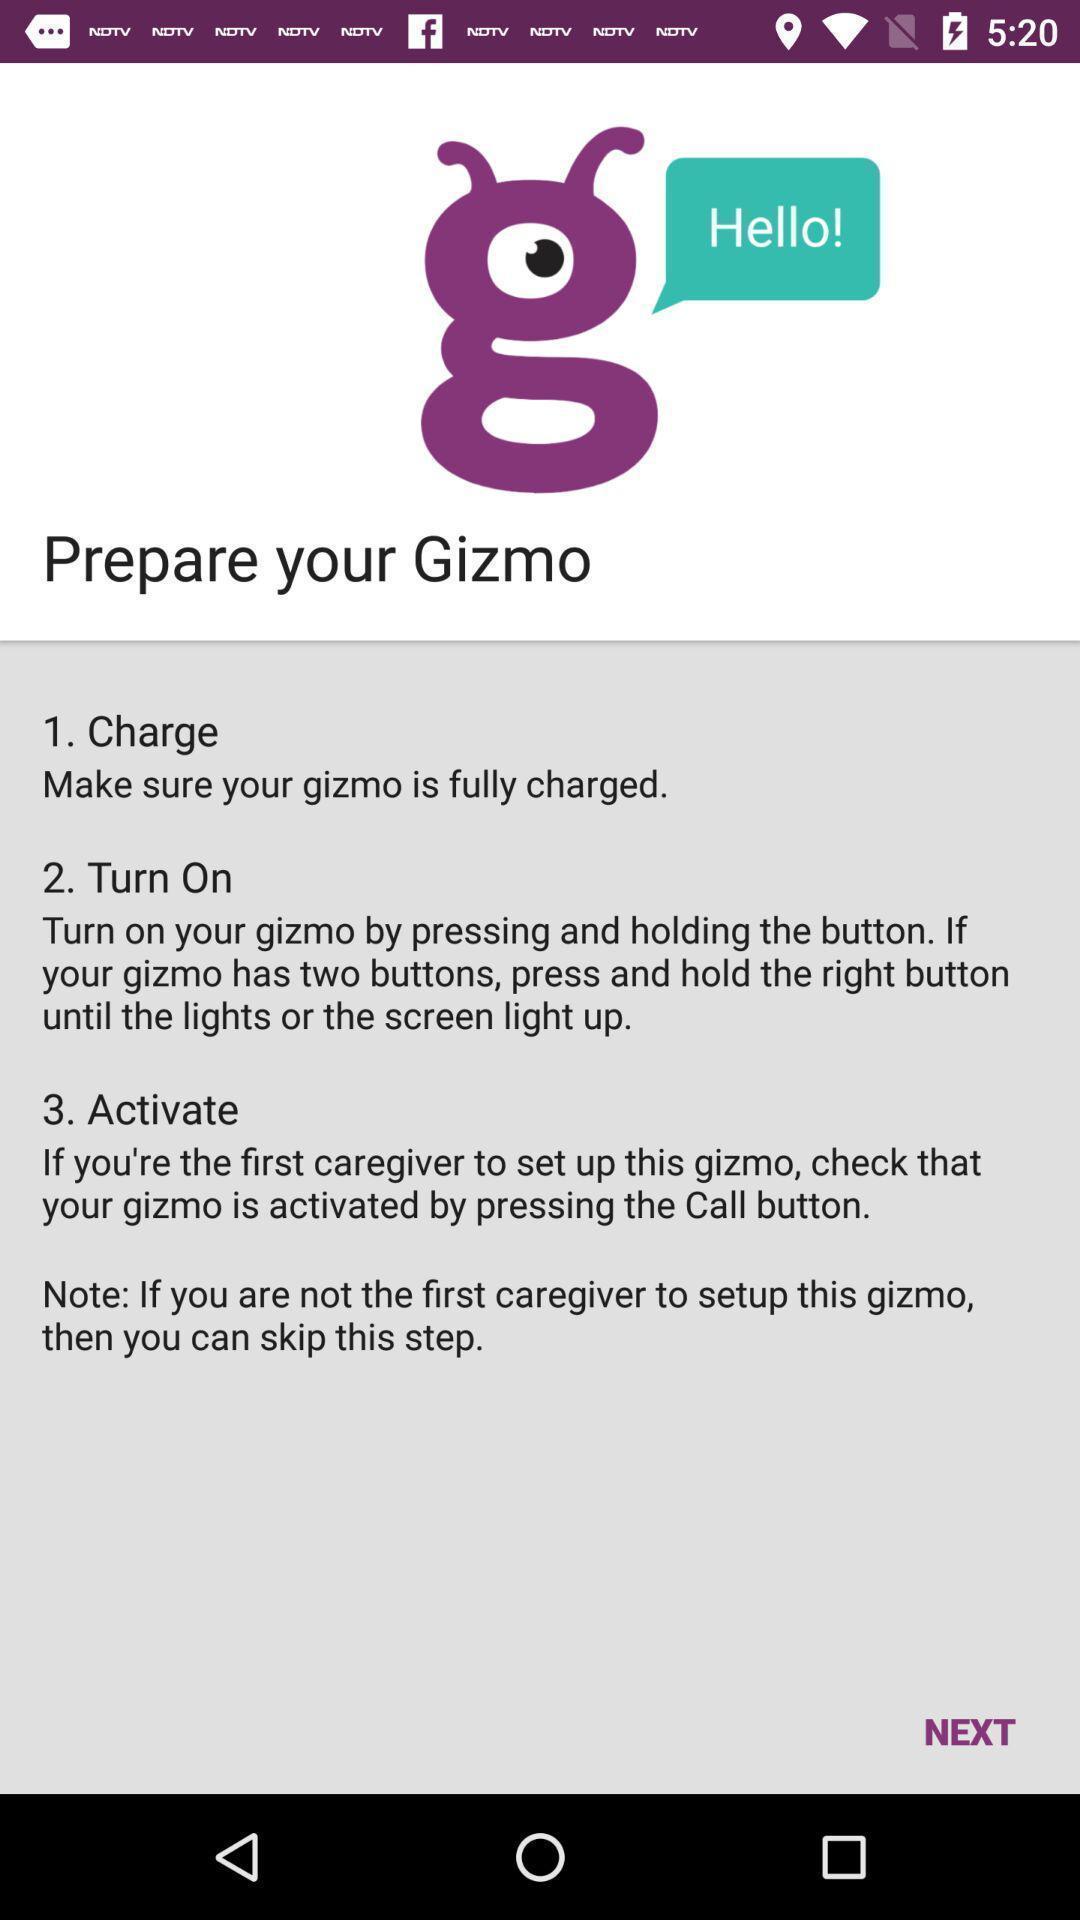Explain the elements present in this screenshot. Set-up page for a geo-tracker device app. 